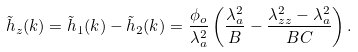Convert formula to latex. <formula><loc_0><loc_0><loc_500><loc_500>\tilde { h } _ { z } ( { k } ) = \tilde { h } _ { 1 } ( { k } ) - \tilde { h } _ { 2 } ( { k } ) = \frac { \phi _ { o } } { \lambda ^ { 2 } _ { a } } \left ( \frac { \lambda ^ { 2 } _ { a } } { B } - \frac { \lambda ^ { 2 } _ { z z } - \lambda ^ { 2 } _ { a } } { B C } \right ) .</formula> 